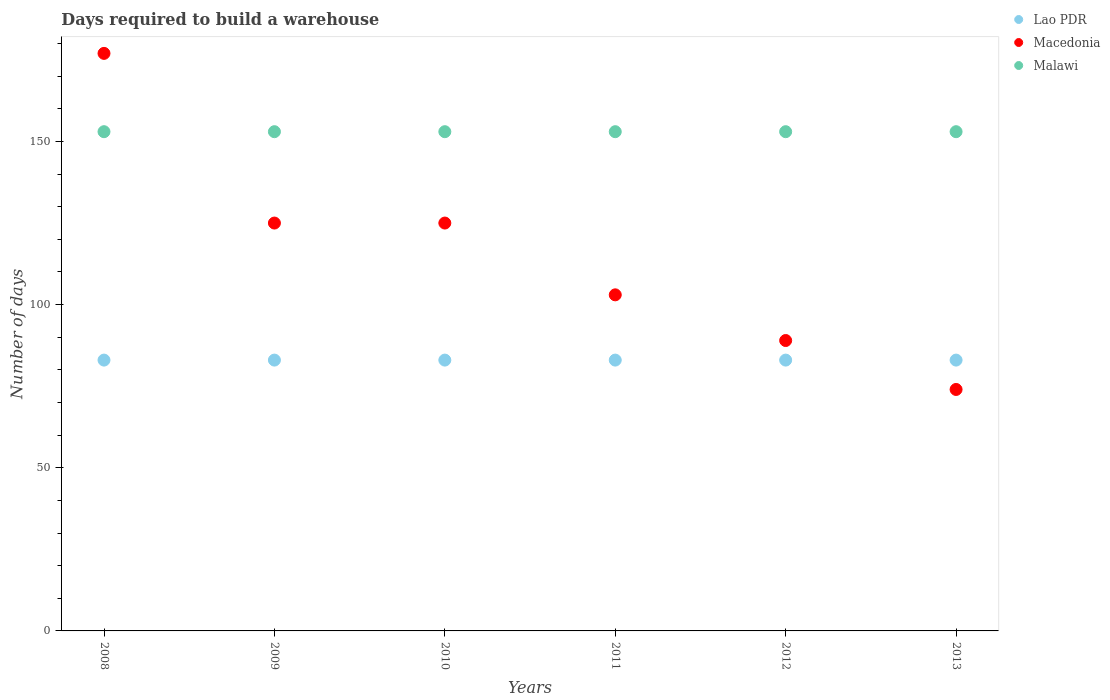How many different coloured dotlines are there?
Provide a short and direct response. 3. What is the days required to build a warehouse in in Lao PDR in 2011?
Keep it short and to the point. 83. Across all years, what is the maximum days required to build a warehouse in in Macedonia?
Your answer should be very brief. 177. Across all years, what is the minimum days required to build a warehouse in in Macedonia?
Make the answer very short. 74. What is the total days required to build a warehouse in in Lao PDR in the graph?
Provide a succinct answer. 498. What is the difference between the days required to build a warehouse in in Lao PDR in 2010 and that in 2013?
Offer a very short reply. 0. What is the difference between the days required to build a warehouse in in Malawi in 2011 and the days required to build a warehouse in in Lao PDR in 2013?
Your response must be concise. 70. What is the average days required to build a warehouse in in Macedonia per year?
Keep it short and to the point. 115.5. In the year 2010, what is the difference between the days required to build a warehouse in in Macedonia and days required to build a warehouse in in Lao PDR?
Give a very brief answer. 42. In how many years, is the days required to build a warehouse in in Macedonia greater than 80 days?
Make the answer very short. 5. What is the ratio of the days required to build a warehouse in in Macedonia in 2011 to that in 2012?
Your answer should be compact. 1.16. Is the difference between the days required to build a warehouse in in Macedonia in 2009 and 2012 greater than the difference between the days required to build a warehouse in in Lao PDR in 2009 and 2012?
Keep it short and to the point. Yes. In how many years, is the days required to build a warehouse in in Macedonia greater than the average days required to build a warehouse in in Macedonia taken over all years?
Ensure brevity in your answer.  3. Is it the case that in every year, the sum of the days required to build a warehouse in in Malawi and days required to build a warehouse in in Macedonia  is greater than the days required to build a warehouse in in Lao PDR?
Offer a very short reply. Yes. Is the days required to build a warehouse in in Macedonia strictly greater than the days required to build a warehouse in in Malawi over the years?
Keep it short and to the point. No. How many dotlines are there?
Your answer should be compact. 3. Are the values on the major ticks of Y-axis written in scientific E-notation?
Offer a very short reply. No. Does the graph contain any zero values?
Provide a short and direct response. No. Does the graph contain grids?
Your response must be concise. No. How many legend labels are there?
Your response must be concise. 3. What is the title of the graph?
Offer a very short reply. Days required to build a warehouse. What is the label or title of the X-axis?
Make the answer very short. Years. What is the label or title of the Y-axis?
Keep it short and to the point. Number of days. What is the Number of days in Lao PDR in 2008?
Your answer should be very brief. 83. What is the Number of days in Macedonia in 2008?
Your answer should be very brief. 177. What is the Number of days of Malawi in 2008?
Keep it short and to the point. 153. What is the Number of days of Macedonia in 2009?
Provide a short and direct response. 125. What is the Number of days of Malawi in 2009?
Your response must be concise. 153. What is the Number of days in Macedonia in 2010?
Make the answer very short. 125. What is the Number of days of Malawi in 2010?
Make the answer very short. 153. What is the Number of days of Lao PDR in 2011?
Offer a terse response. 83. What is the Number of days of Macedonia in 2011?
Provide a short and direct response. 103. What is the Number of days of Malawi in 2011?
Ensure brevity in your answer.  153. What is the Number of days of Macedonia in 2012?
Ensure brevity in your answer.  89. What is the Number of days of Malawi in 2012?
Your answer should be compact. 153. What is the Number of days in Malawi in 2013?
Give a very brief answer. 153. Across all years, what is the maximum Number of days in Macedonia?
Give a very brief answer. 177. Across all years, what is the maximum Number of days in Malawi?
Provide a short and direct response. 153. Across all years, what is the minimum Number of days in Lao PDR?
Your answer should be very brief. 83. Across all years, what is the minimum Number of days in Macedonia?
Your answer should be compact. 74. Across all years, what is the minimum Number of days of Malawi?
Your response must be concise. 153. What is the total Number of days in Lao PDR in the graph?
Provide a short and direct response. 498. What is the total Number of days of Macedonia in the graph?
Your response must be concise. 693. What is the total Number of days in Malawi in the graph?
Offer a very short reply. 918. What is the difference between the Number of days in Lao PDR in 2008 and that in 2009?
Provide a short and direct response. 0. What is the difference between the Number of days in Malawi in 2008 and that in 2010?
Provide a succinct answer. 0. What is the difference between the Number of days of Lao PDR in 2008 and that in 2011?
Ensure brevity in your answer.  0. What is the difference between the Number of days of Malawi in 2008 and that in 2011?
Provide a short and direct response. 0. What is the difference between the Number of days in Lao PDR in 2008 and that in 2012?
Offer a very short reply. 0. What is the difference between the Number of days of Macedonia in 2008 and that in 2012?
Ensure brevity in your answer.  88. What is the difference between the Number of days in Malawi in 2008 and that in 2012?
Offer a terse response. 0. What is the difference between the Number of days of Macedonia in 2008 and that in 2013?
Ensure brevity in your answer.  103. What is the difference between the Number of days in Lao PDR in 2009 and that in 2010?
Your response must be concise. 0. What is the difference between the Number of days of Lao PDR in 2009 and that in 2011?
Provide a short and direct response. 0. What is the difference between the Number of days in Malawi in 2009 and that in 2012?
Ensure brevity in your answer.  0. What is the difference between the Number of days in Malawi in 2009 and that in 2013?
Keep it short and to the point. 0. What is the difference between the Number of days in Lao PDR in 2010 and that in 2012?
Provide a succinct answer. 0. What is the difference between the Number of days of Malawi in 2010 and that in 2012?
Make the answer very short. 0. What is the difference between the Number of days in Lao PDR in 2010 and that in 2013?
Your answer should be compact. 0. What is the difference between the Number of days in Malawi in 2010 and that in 2013?
Provide a succinct answer. 0. What is the difference between the Number of days of Macedonia in 2011 and that in 2012?
Give a very brief answer. 14. What is the difference between the Number of days in Malawi in 2011 and that in 2012?
Offer a terse response. 0. What is the difference between the Number of days of Macedonia in 2011 and that in 2013?
Your answer should be compact. 29. What is the difference between the Number of days of Malawi in 2011 and that in 2013?
Offer a very short reply. 0. What is the difference between the Number of days of Lao PDR in 2012 and that in 2013?
Offer a terse response. 0. What is the difference between the Number of days of Malawi in 2012 and that in 2013?
Offer a very short reply. 0. What is the difference between the Number of days in Lao PDR in 2008 and the Number of days in Macedonia in 2009?
Ensure brevity in your answer.  -42. What is the difference between the Number of days in Lao PDR in 2008 and the Number of days in Malawi in 2009?
Your answer should be compact. -70. What is the difference between the Number of days of Macedonia in 2008 and the Number of days of Malawi in 2009?
Give a very brief answer. 24. What is the difference between the Number of days of Lao PDR in 2008 and the Number of days of Macedonia in 2010?
Your response must be concise. -42. What is the difference between the Number of days of Lao PDR in 2008 and the Number of days of Malawi in 2010?
Ensure brevity in your answer.  -70. What is the difference between the Number of days of Lao PDR in 2008 and the Number of days of Macedonia in 2011?
Offer a very short reply. -20. What is the difference between the Number of days in Lao PDR in 2008 and the Number of days in Malawi in 2011?
Give a very brief answer. -70. What is the difference between the Number of days of Lao PDR in 2008 and the Number of days of Macedonia in 2012?
Your answer should be very brief. -6. What is the difference between the Number of days in Lao PDR in 2008 and the Number of days in Malawi in 2012?
Provide a short and direct response. -70. What is the difference between the Number of days of Macedonia in 2008 and the Number of days of Malawi in 2012?
Make the answer very short. 24. What is the difference between the Number of days of Lao PDR in 2008 and the Number of days of Malawi in 2013?
Provide a short and direct response. -70. What is the difference between the Number of days of Macedonia in 2008 and the Number of days of Malawi in 2013?
Offer a terse response. 24. What is the difference between the Number of days of Lao PDR in 2009 and the Number of days of Macedonia in 2010?
Offer a very short reply. -42. What is the difference between the Number of days of Lao PDR in 2009 and the Number of days of Malawi in 2010?
Make the answer very short. -70. What is the difference between the Number of days in Lao PDR in 2009 and the Number of days in Malawi in 2011?
Ensure brevity in your answer.  -70. What is the difference between the Number of days in Lao PDR in 2009 and the Number of days in Malawi in 2012?
Provide a short and direct response. -70. What is the difference between the Number of days in Macedonia in 2009 and the Number of days in Malawi in 2012?
Provide a short and direct response. -28. What is the difference between the Number of days of Lao PDR in 2009 and the Number of days of Malawi in 2013?
Ensure brevity in your answer.  -70. What is the difference between the Number of days in Macedonia in 2009 and the Number of days in Malawi in 2013?
Provide a short and direct response. -28. What is the difference between the Number of days in Lao PDR in 2010 and the Number of days in Macedonia in 2011?
Provide a short and direct response. -20. What is the difference between the Number of days in Lao PDR in 2010 and the Number of days in Malawi in 2011?
Keep it short and to the point. -70. What is the difference between the Number of days in Macedonia in 2010 and the Number of days in Malawi in 2011?
Make the answer very short. -28. What is the difference between the Number of days of Lao PDR in 2010 and the Number of days of Malawi in 2012?
Your answer should be compact. -70. What is the difference between the Number of days of Macedonia in 2010 and the Number of days of Malawi in 2012?
Your answer should be compact. -28. What is the difference between the Number of days in Lao PDR in 2010 and the Number of days in Macedonia in 2013?
Offer a very short reply. 9. What is the difference between the Number of days in Lao PDR in 2010 and the Number of days in Malawi in 2013?
Ensure brevity in your answer.  -70. What is the difference between the Number of days in Lao PDR in 2011 and the Number of days in Macedonia in 2012?
Give a very brief answer. -6. What is the difference between the Number of days of Lao PDR in 2011 and the Number of days of Malawi in 2012?
Your answer should be very brief. -70. What is the difference between the Number of days in Macedonia in 2011 and the Number of days in Malawi in 2012?
Provide a short and direct response. -50. What is the difference between the Number of days in Lao PDR in 2011 and the Number of days in Macedonia in 2013?
Offer a very short reply. 9. What is the difference between the Number of days in Lao PDR in 2011 and the Number of days in Malawi in 2013?
Ensure brevity in your answer.  -70. What is the difference between the Number of days of Macedonia in 2011 and the Number of days of Malawi in 2013?
Give a very brief answer. -50. What is the difference between the Number of days in Lao PDR in 2012 and the Number of days in Macedonia in 2013?
Provide a short and direct response. 9. What is the difference between the Number of days of Lao PDR in 2012 and the Number of days of Malawi in 2013?
Make the answer very short. -70. What is the difference between the Number of days of Macedonia in 2012 and the Number of days of Malawi in 2013?
Offer a very short reply. -64. What is the average Number of days of Macedonia per year?
Give a very brief answer. 115.5. What is the average Number of days in Malawi per year?
Offer a terse response. 153. In the year 2008, what is the difference between the Number of days of Lao PDR and Number of days of Macedonia?
Ensure brevity in your answer.  -94. In the year 2008, what is the difference between the Number of days of Lao PDR and Number of days of Malawi?
Your answer should be compact. -70. In the year 2009, what is the difference between the Number of days of Lao PDR and Number of days of Macedonia?
Keep it short and to the point. -42. In the year 2009, what is the difference between the Number of days in Lao PDR and Number of days in Malawi?
Offer a terse response. -70. In the year 2009, what is the difference between the Number of days of Macedonia and Number of days of Malawi?
Ensure brevity in your answer.  -28. In the year 2010, what is the difference between the Number of days in Lao PDR and Number of days in Macedonia?
Ensure brevity in your answer.  -42. In the year 2010, what is the difference between the Number of days of Lao PDR and Number of days of Malawi?
Offer a very short reply. -70. In the year 2010, what is the difference between the Number of days in Macedonia and Number of days in Malawi?
Provide a succinct answer. -28. In the year 2011, what is the difference between the Number of days of Lao PDR and Number of days of Malawi?
Provide a succinct answer. -70. In the year 2012, what is the difference between the Number of days in Lao PDR and Number of days in Macedonia?
Ensure brevity in your answer.  -6. In the year 2012, what is the difference between the Number of days in Lao PDR and Number of days in Malawi?
Your answer should be very brief. -70. In the year 2012, what is the difference between the Number of days in Macedonia and Number of days in Malawi?
Offer a very short reply. -64. In the year 2013, what is the difference between the Number of days of Lao PDR and Number of days of Malawi?
Offer a terse response. -70. In the year 2013, what is the difference between the Number of days in Macedonia and Number of days in Malawi?
Your response must be concise. -79. What is the ratio of the Number of days in Lao PDR in 2008 to that in 2009?
Give a very brief answer. 1. What is the ratio of the Number of days of Macedonia in 2008 to that in 2009?
Provide a succinct answer. 1.42. What is the ratio of the Number of days in Lao PDR in 2008 to that in 2010?
Your response must be concise. 1. What is the ratio of the Number of days in Macedonia in 2008 to that in 2010?
Keep it short and to the point. 1.42. What is the ratio of the Number of days in Malawi in 2008 to that in 2010?
Your response must be concise. 1. What is the ratio of the Number of days of Lao PDR in 2008 to that in 2011?
Provide a succinct answer. 1. What is the ratio of the Number of days of Macedonia in 2008 to that in 2011?
Keep it short and to the point. 1.72. What is the ratio of the Number of days in Malawi in 2008 to that in 2011?
Give a very brief answer. 1. What is the ratio of the Number of days in Lao PDR in 2008 to that in 2012?
Your answer should be very brief. 1. What is the ratio of the Number of days in Macedonia in 2008 to that in 2012?
Provide a short and direct response. 1.99. What is the ratio of the Number of days in Malawi in 2008 to that in 2012?
Provide a succinct answer. 1. What is the ratio of the Number of days in Lao PDR in 2008 to that in 2013?
Make the answer very short. 1. What is the ratio of the Number of days in Macedonia in 2008 to that in 2013?
Offer a very short reply. 2.39. What is the ratio of the Number of days of Malawi in 2008 to that in 2013?
Give a very brief answer. 1. What is the ratio of the Number of days in Lao PDR in 2009 to that in 2010?
Provide a succinct answer. 1. What is the ratio of the Number of days of Malawi in 2009 to that in 2010?
Offer a very short reply. 1. What is the ratio of the Number of days in Lao PDR in 2009 to that in 2011?
Give a very brief answer. 1. What is the ratio of the Number of days of Macedonia in 2009 to that in 2011?
Offer a very short reply. 1.21. What is the ratio of the Number of days of Macedonia in 2009 to that in 2012?
Offer a very short reply. 1.4. What is the ratio of the Number of days of Macedonia in 2009 to that in 2013?
Ensure brevity in your answer.  1.69. What is the ratio of the Number of days in Lao PDR in 2010 to that in 2011?
Make the answer very short. 1. What is the ratio of the Number of days of Macedonia in 2010 to that in 2011?
Your answer should be compact. 1.21. What is the ratio of the Number of days in Malawi in 2010 to that in 2011?
Provide a succinct answer. 1. What is the ratio of the Number of days in Lao PDR in 2010 to that in 2012?
Your answer should be very brief. 1. What is the ratio of the Number of days in Macedonia in 2010 to that in 2012?
Ensure brevity in your answer.  1.4. What is the ratio of the Number of days of Malawi in 2010 to that in 2012?
Ensure brevity in your answer.  1. What is the ratio of the Number of days in Lao PDR in 2010 to that in 2013?
Your answer should be compact. 1. What is the ratio of the Number of days in Macedonia in 2010 to that in 2013?
Provide a short and direct response. 1.69. What is the ratio of the Number of days of Malawi in 2010 to that in 2013?
Make the answer very short. 1. What is the ratio of the Number of days of Lao PDR in 2011 to that in 2012?
Give a very brief answer. 1. What is the ratio of the Number of days of Macedonia in 2011 to that in 2012?
Offer a terse response. 1.16. What is the ratio of the Number of days of Macedonia in 2011 to that in 2013?
Offer a very short reply. 1.39. What is the ratio of the Number of days in Malawi in 2011 to that in 2013?
Provide a succinct answer. 1. What is the ratio of the Number of days of Macedonia in 2012 to that in 2013?
Ensure brevity in your answer.  1.2. What is the difference between the highest and the second highest Number of days of Macedonia?
Provide a succinct answer. 52. What is the difference between the highest and the lowest Number of days in Macedonia?
Your response must be concise. 103. What is the difference between the highest and the lowest Number of days of Malawi?
Ensure brevity in your answer.  0. 